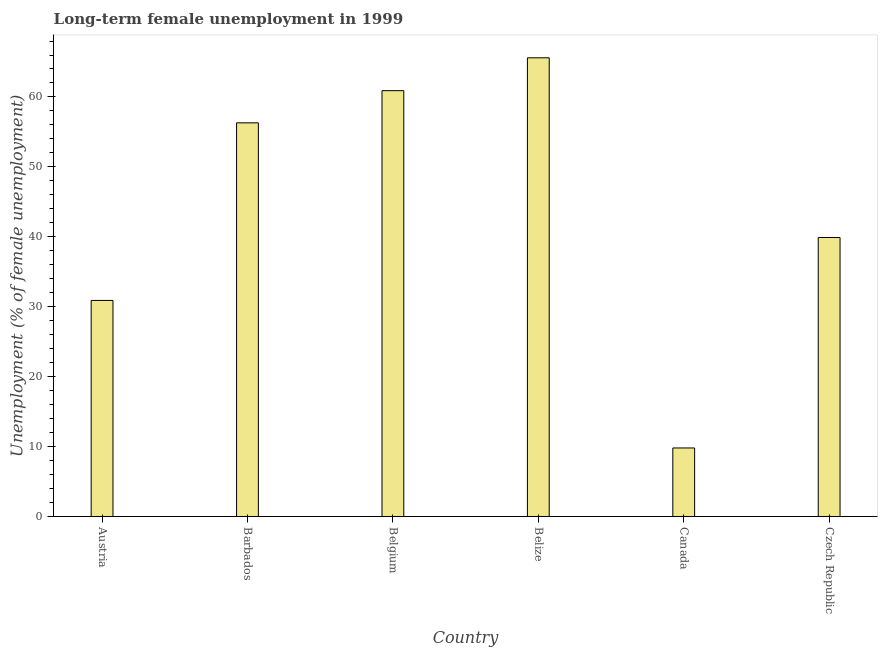What is the title of the graph?
Offer a terse response. Long-term female unemployment in 1999. What is the label or title of the X-axis?
Provide a succinct answer. Country. What is the label or title of the Y-axis?
Give a very brief answer. Unemployment (% of female unemployment). What is the long-term female unemployment in Belize?
Offer a very short reply. 65.6. Across all countries, what is the maximum long-term female unemployment?
Ensure brevity in your answer.  65.6. Across all countries, what is the minimum long-term female unemployment?
Offer a terse response. 9.8. In which country was the long-term female unemployment maximum?
Offer a terse response. Belize. What is the sum of the long-term female unemployment?
Your answer should be very brief. 263.4. What is the difference between the long-term female unemployment in Austria and Barbados?
Your response must be concise. -25.4. What is the average long-term female unemployment per country?
Give a very brief answer. 43.9. What is the median long-term female unemployment?
Your response must be concise. 48.1. In how many countries, is the long-term female unemployment greater than 8 %?
Your response must be concise. 6. What is the ratio of the long-term female unemployment in Barbados to that in Belize?
Give a very brief answer. 0.86. Is the long-term female unemployment in Belgium less than that in Belize?
Provide a short and direct response. Yes. What is the difference between the highest and the second highest long-term female unemployment?
Offer a very short reply. 4.7. Is the sum of the long-term female unemployment in Belgium and Canada greater than the maximum long-term female unemployment across all countries?
Ensure brevity in your answer.  Yes. What is the difference between the highest and the lowest long-term female unemployment?
Your response must be concise. 55.8. In how many countries, is the long-term female unemployment greater than the average long-term female unemployment taken over all countries?
Your answer should be very brief. 3. How many bars are there?
Offer a very short reply. 6. Are all the bars in the graph horizontal?
Your answer should be very brief. No. How many countries are there in the graph?
Your answer should be compact. 6. Are the values on the major ticks of Y-axis written in scientific E-notation?
Offer a terse response. No. What is the Unemployment (% of female unemployment) in Austria?
Offer a very short reply. 30.9. What is the Unemployment (% of female unemployment) of Barbados?
Provide a succinct answer. 56.3. What is the Unemployment (% of female unemployment) of Belgium?
Keep it short and to the point. 60.9. What is the Unemployment (% of female unemployment) in Belize?
Provide a short and direct response. 65.6. What is the Unemployment (% of female unemployment) in Canada?
Give a very brief answer. 9.8. What is the Unemployment (% of female unemployment) in Czech Republic?
Your answer should be very brief. 39.9. What is the difference between the Unemployment (% of female unemployment) in Austria and Barbados?
Your answer should be very brief. -25.4. What is the difference between the Unemployment (% of female unemployment) in Austria and Belize?
Provide a short and direct response. -34.7. What is the difference between the Unemployment (% of female unemployment) in Austria and Canada?
Ensure brevity in your answer.  21.1. What is the difference between the Unemployment (% of female unemployment) in Barbados and Belize?
Your response must be concise. -9.3. What is the difference between the Unemployment (% of female unemployment) in Barbados and Canada?
Offer a terse response. 46.5. What is the difference between the Unemployment (% of female unemployment) in Belgium and Canada?
Ensure brevity in your answer.  51.1. What is the difference between the Unemployment (% of female unemployment) in Belize and Canada?
Provide a succinct answer. 55.8. What is the difference between the Unemployment (% of female unemployment) in Belize and Czech Republic?
Offer a very short reply. 25.7. What is the difference between the Unemployment (% of female unemployment) in Canada and Czech Republic?
Make the answer very short. -30.1. What is the ratio of the Unemployment (% of female unemployment) in Austria to that in Barbados?
Offer a terse response. 0.55. What is the ratio of the Unemployment (% of female unemployment) in Austria to that in Belgium?
Make the answer very short. 0.51. What is the ratio of the Unemployment (% of female unemployment) in Austria to that in Belize?
Offer a terse response. 0.47. What is the ratio of the Unemployment (% of female unemployment) in Austria to that in Canada?
Your answer should be very brief. 3.15. What is the ratio of the Unemployment (% of female unemployment) in Austria to that in Czech Republic?
Provide a succinct answer. 0.77. What is the ratio of the Unemployment (% of female unemployment) in Barbados to that in Belgium?
Make the answer very short. 0.92. What is the ratio of the Unemployment (% of female unemployment) in Barbados to that in Belize?
Make the answer very short. 0.86. What is the ratio of the Unemployment (% of female unemployment) in Barbados to that in Canada?
Offer a very short reply. 5.75. What is the ratio of the Unemployment (% of female unemployment) in Barbados to that in Czech Republic?
Offer a very short reply. 1.41. What is the ratio of the Unemployment (% of female unemployment) in Belgium to that in Belize?
Make the answer very short. 0.93. What is the ratio of the Unemployment (% of female unemployment) in Belgium to that in Canada?
Give a very brief answer. 6.21. What is the ratio of the Unemployment (% of female unemployment) in Belgium to that in Czech Republic?
Ensure brevity in your answer.  1.53. What is the ratio of the Unemployment (% of female unemployment) in Belize to that in Canada?
Your answer should be compact. 6.69. What is the ratio of the Unemployment (% of female unemployment) in Belize to that in Czech Republic?
Ensure brevity in your answer.  1.64. What is the ratio of the Unemployment (% of female unemployment) in Canada to that in Czech Republic?
Your response must be concise. 0.25. 